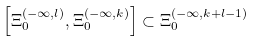Convert formula to latex. <formula><loc_0><loc_0><loc_500><loc_500>\left [ \Xi _ { 0 } ^ { ( - \infty , l ) } , \Xi _ { 0 } ^ { ( - \infty , k ) } \right ] \subset \Xi _ { 0 } ^ { ( - \infty , k + l - 1 ) }</formula> 